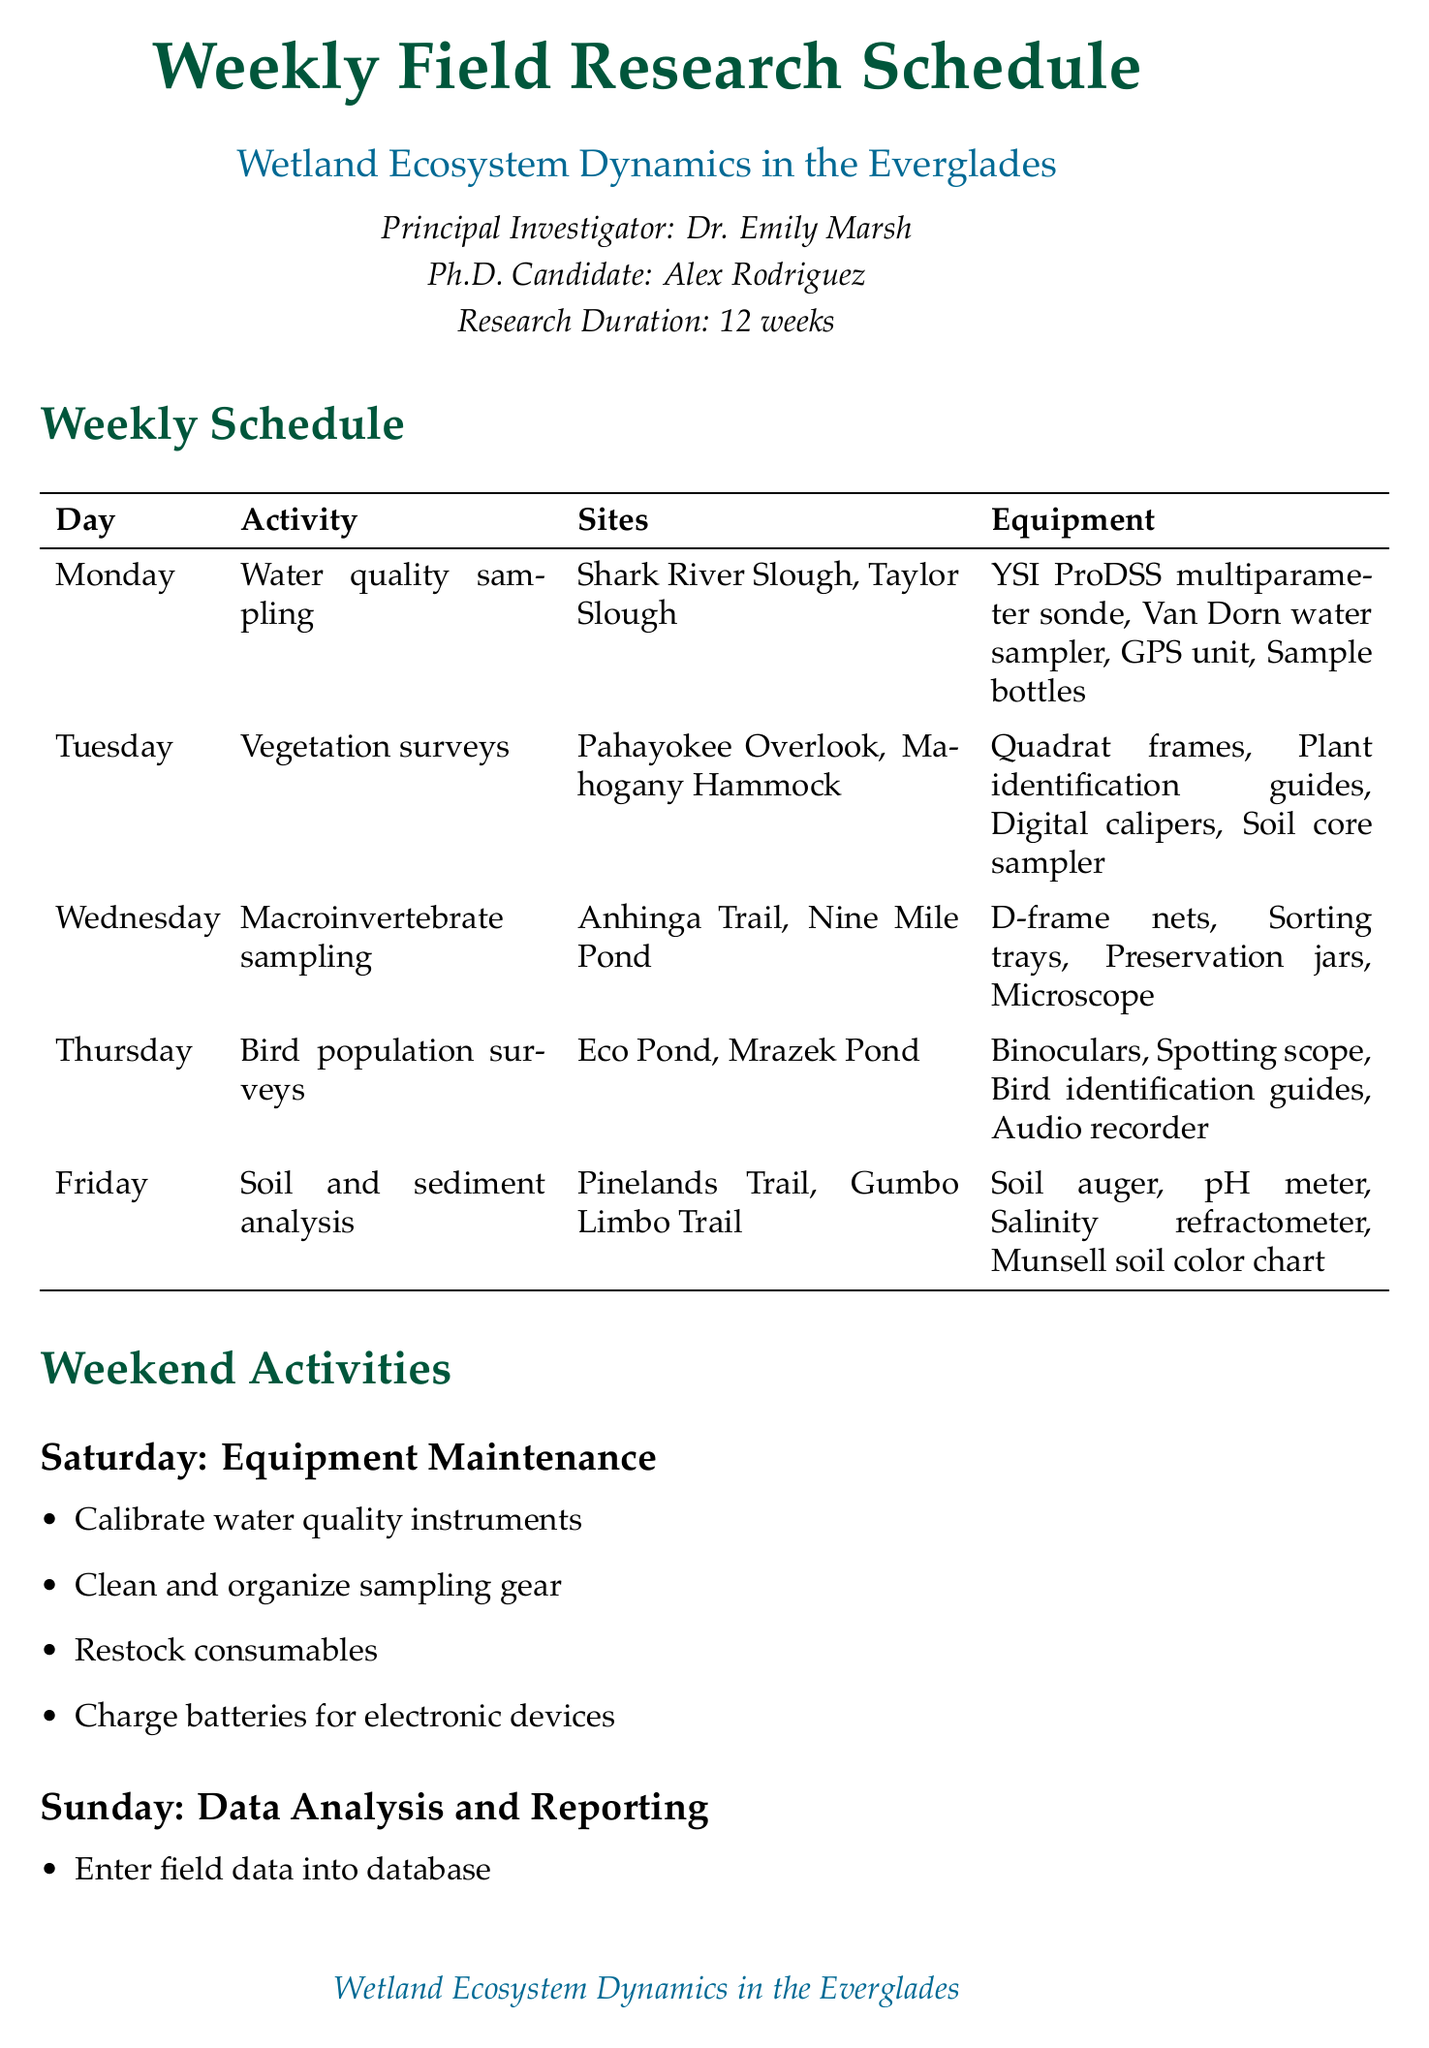what is the project title? The project title is provided in the document as "Wetland Ecosystem Dynamics in the Everglades."
Answer: Wetland Ecosystem Dynamics in the Everglades who is the principal investigator? The principal investigator is mentioned in the document as Dr. Emily Marsh.
Answer: Dr. Emily Marsh how many weeks does the research last? The duration of the research is specified as "12 weeks."
Answer: 12 weeks which sites are designated for water quality sampling? The document lists "Shark River Slough" and "Taylor Slough" as the sampling sites for water quality.
Answer: Shark River Slough, Taylor Slough what activity is planned for Wednesday? The activity scheduled for Wednesday is "Macroinvertebrate sampling."
Answer: Macroinvertebrate sampling what equipment is required for soil and sediment analysis? The document outlines specific equipment like "Soil auger, pH meter, Salinity refractometer, Munsell soil color chart" for this activity.
Answer: Soil auger, pH meter, Salinity refractometer, Munsell soil color chart how often is equipment maintenance scheduled? Equipment maintenance is scheduled for every Saturday according to the document.
Answer: Saturday what is the first task for data analysis and reporting on Sunday? The first task listed for Sunday is "Enter field data into database."
Answer: Enter field data into database what safety protocol suggests working in pairs? The safety protocol states, "Always work in pairs when in the field."
Answer: Always work in pairs when in the field what is one of the additional notes provided in the document? One of the additional notes says to "Coordinate with park rangers for site access."
Answer: Coordinate with park rangers for site access 